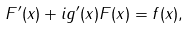Convert formula to latex. <formula><loc_0><loc_0><loc_500><loc_500>F ^ { \prime } ( x ) + i g ^ { \prime } ( x ) F ( x ) = f ( x ) ,</formula> 